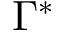<formula> <loc_0><loc_0><loc_500><loc_500>\Gamma ^ { * }</formula> 